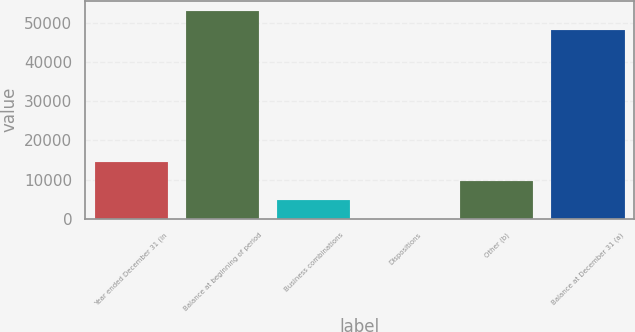Convert chart. <chart><loc_0><loc_0><loc_500><loc_500><bar_chart><fcel>Year ended December 31 (in<fcel>Balance at beginning of period<fcel>Business combinations<fcel>Dispositions<fcel>Other (b)<fcel>Balance at December 31 (a)<nl><fcel>14459.2<fcel>52993.4<fcel>4822.4<fcel>4<fcel>9640.8<fcel>48175<nl></chart> 